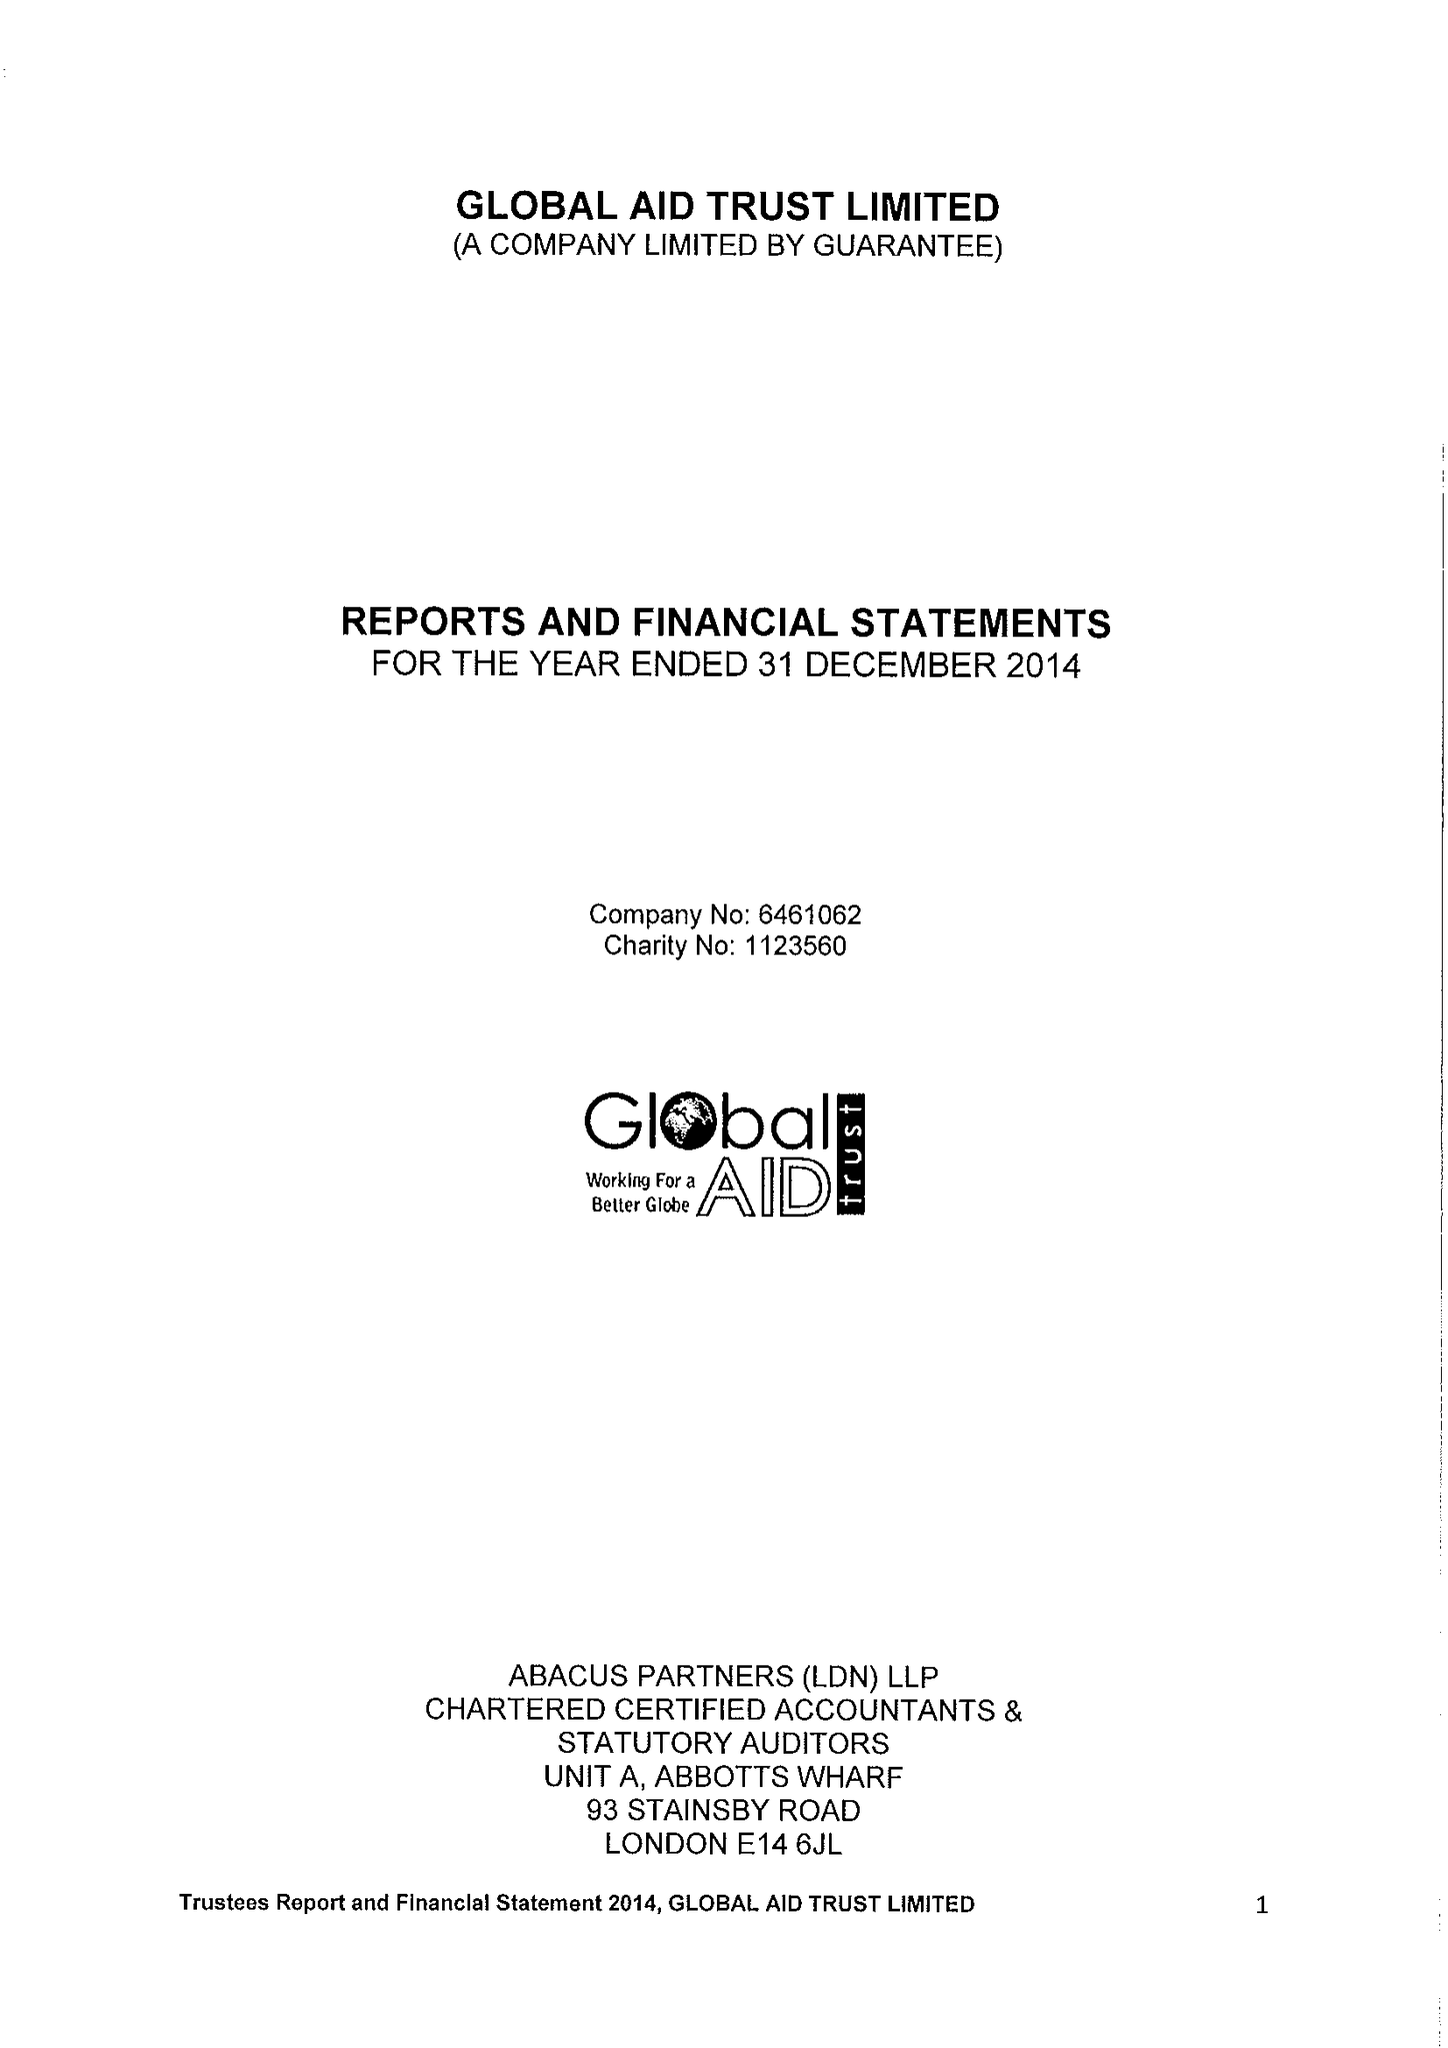What is the value for the charity_name?
Answer the question using a single word or phrase. Global Aid Trust Ltd. 